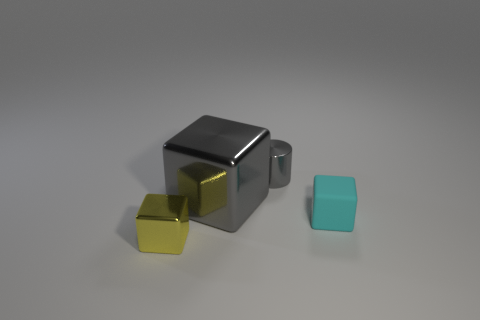Add 1 yellow shiny blocks. How many objects exist? 5 Subtract all small cubes. How many cubes are left? 1 Subtract 1 cylinders. How many cylinders are left? 0 Subtract all blocks. How many objects are left? 1 Subtract all cyan rubber blocks. Subtract all big cubes. How many objects are left? 2 Add 1 rubber objects. How many rubber objects are left? 2 Add 3 small green shiny blocks. How many small green shiny blocks exist? 3 Subtract 0 yellow cylinders. How many objects are left? 4 Subtract all brown cylinders. Subtract all red spheres. How many cylinders are left? 1 Subtract all cyan balls. How many cyan blocks are left? 1 